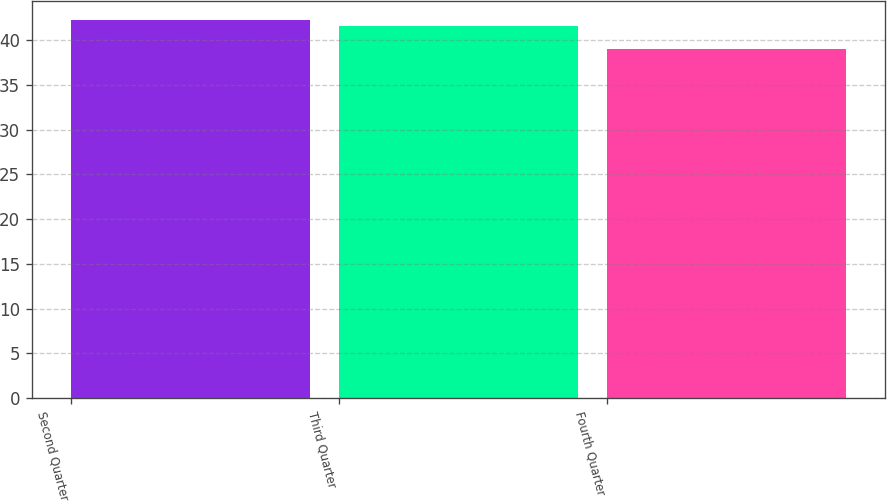<chart> <loc_0><loc_0><loc_500><loc_500><bar_chart><fcel>Second Quarter<fcel>Third Quarter<fcel>Fourth Quarter<nl><fcel>42.29<fcel>41.57<fcel>39.04<nl></chart> 